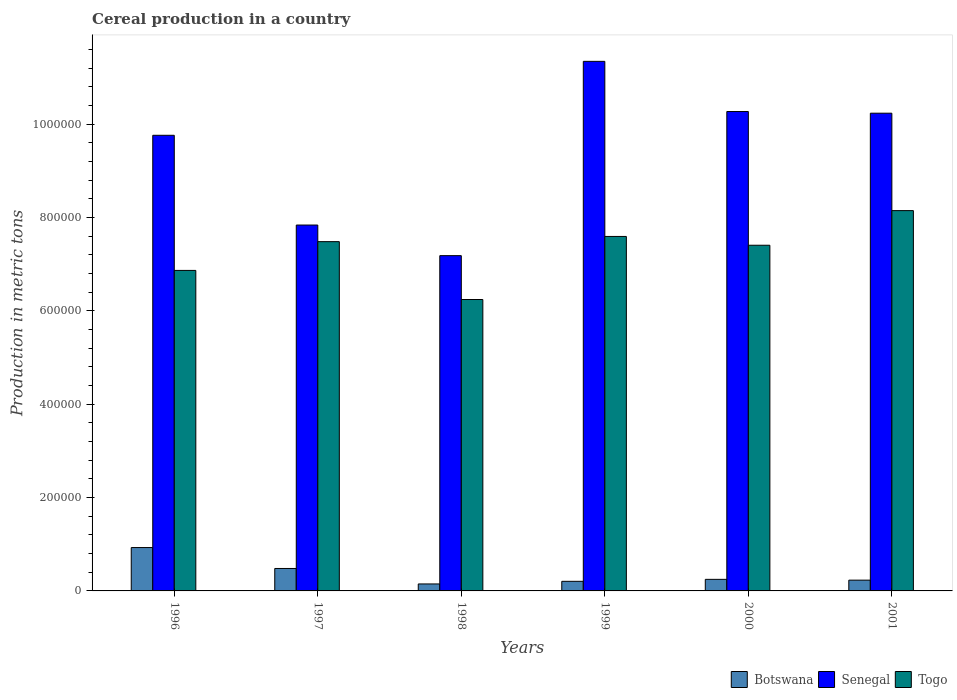Are the number of bars per tick equal to the number of legend labels?
Offer a very short reply. Yes. How many bars are there on the 4th tick from the left?
Your answer should be compact. 3. How many bars are there on the 2nd tick from the right?
Ensure brevity in your answer.  3. What is the label of the 5th group of bars from the left?
Ensure brevity in your answer.  2000. In how many cases, is the number of bars for a given year not equal to the number of legend labels?
Ensure brevity in your answer.  0. What is the total cereal production in Togo in 1996?
Your answer should be very brief. 6.87e+05. Across all years, what is the maximum total cereal production in Togo?
Give a very brief answer. 8.15e+05. Across all years, what is the minimum total cereal production in Botswana?
Your answer should be very brief. 1.49e+04. What is the total total cereal production in Botswana in the graph?
Provide a succinct answer. 2.24e+05. What is the difference between the total cereal production in Togo in 1996 and that in 1999?
Your answer should be very brief. -7.28e+04. What is the difference between the total cereal production in Senegal in 1997 and the total cereal production in Botswana in 1998?
Give a very brief answer. 7.69e+05. What is the average total cereal production in Senegal per year?
Provide a short and direct response. 9.44e+05. In the year 1998, what is the difference between the total cereal production in Togo and total cereal production in Senegal?
Your response must be concise. -9.40e+04. What is the ratio of the total cereal production in Botswana in 1997 to that in 2000?
Give a very brief answer. 1.94. What is the difference between the highest and the second highest total cereal production in Togo?
Give a very brief answer. 5.53e+04. What is the difference between the highest and the lowest total cereal production in Togo?
Your response must be concise. 1.90e+05. What does the 3rd bar from the left in 2001 represents?
Your answer should be very brief. Togo. What does the 3rd bar from the right in 2001 represents?
Keep it short and to the point. Botswana. Are all the bars in the graph horizontal?
Keep it short and to the point. No. How many years are there in the graph?
Provide a short and direct response. 6. What is the difference between two consecutive major ticks on the Y-axis?
Make the answer very short. 2.00e+05. Does the graph contain any zero values?
Offer a terse response. No. Where does the legend appear in the graph?
Offer a very short reply. Bottom right. How many legend labels are there?
Keep it short and to the point. 3. How are the legend labels stacked?
Provide a short and direct response. Horizontal. What is the title of the graph?
Your answer should be compact. Cereal production in a country. What is the label or title of the X-axis?
Offer a very short reply. Years. What is the label or title of the Y-axis?
Your response must be concise. Production in metric tons. What is the Production in metric tons in Botswana in 1996?
Offer a very short reply. 9.29e+04. What is the Production in metric tons of Senegal in 1996?
Offer a very short reply. 9.76e+05. What is the Production in metric tons in Togo in 1996?
Ensure brevity in your answer.  6.87e+05. What is the Production in metric tons of Botswana in 1997?
Keep it short and to the point. 4.81e+04. What is the Production in metric tons in Senegal in 1997?
Provide a short and direct response. 7.84e+05. What is the Production in metric tons in Togo in 1997?
Provide a succinct answer. 7.48e+05. What is the Production in metric tons of Botswana in 1998?
Your answer should be very brief. 1.49e+04. What is the Production in metric tons of Senegal in 1998?
Make the answer very short. 7.18e+05. What is the Production in metric tons of Togo in 1998?
Your answer should be very brief. 6.24e+05. What is the Production in metric tons of Botswana in 1999?
Offer a very short reply. 2.06e+04. What is the Production in metric tons of Senegal in 1999?
Your answer should be very brief. 1.13e+06. What is the Production in metric tons in Togo in 1999?
Offer a terse response. 7.59e+05. What is the Production in metric tons of Botswana in 2000?
Give a very brief answer. 2.48e+04. What is the Production in metric tons of Senegal in 2000?
Offer a terse response. 1.03e+06. What is the Production in metric tons in Togo in 2000?
Offer a terse response. 7.41e+05. What is the Production in metric tons in Botswana in 2001?
Offer a very short reply. 2.31e+04. What is the Production in metric tons of Senegal in 2001?
Keep it short and to the point. 1.02e+06. What is the Production in metric tons in Togo in 2001?
Provide a short and direct response. 8.15e+05. Across all years, what is the maximum Production in metric tons of Botswana?
Provide a short and direct response. 9.29e+04. Across all years, what is the maximum Production in metric tons in Senegal?
Ensure brevity in your answer.  1.13e+06. Across all years, what is the maximum Production in metric tons in Togo?
Make the answer very short. 8.15e+05. Across all years, what is the minimum Production in metric tons of Botswana?
Provide a succinct answer. 1.49e+04. Across all years, what is the minimum Production in metric tons in Senegal?
Provide a succinct answer. 7.18e+05. Across all years, what is the minimum Production in metric tons in Togo?
Give a very brief answer. 6.24e+05. What is the total Production in metric tons of Botswana in the graph?
Your response must be concise. 2.24e+05. What is the total Production in metric tons in Senegal in the graph?
Offer a terse response. 5.66e+06. What is the total Production in metric tons in Togo in the graph?
Provide a succinct answer. 4.37e+06. What is the difference between the Production in metric tons of Botswana in 1996 and that in 1997?
Your response must be concise. 4.48e+04. What is the difference between the Production in metric tons in Senegal in 1996 and that in 1997?
Your response must be concise. 1.92e+05. What is the difference between the Production in metric tons of Togo in 1996 and that in 1997?
Provide a short and direct response. -6.16e+04. What is the difference between the Production in metric tons in Botswana in 1996 and that in 1998?
Your response must be concise. 7.80e+04. What is the difference between the Production in metric tons of Senegal in 1996 and that in 1998?
Keep it short and to the point. 2.58e+05. What is the difference between the Production in metric tons of Togo in 1996 and that in 1998?
Your answer should be very brief. 6.23e+04. What is the difference between the Production in metric tons of Botswana in 1996 and that in 1999?
Provide a short and direct response. 7.23e+04. What is the difference between the Production in metric tons in Senegal in 1996 and that in 1999?
Your answer should be very brief. -1.58e+05. What is the difference between the Production in metric tons of Togo in 1996 and that in 1999?
Ensure brevity in your answer.  -7.28e+04. What is the difference between the Production in metric tons in Botswana in 1996 and that in 2000?
Offer a terse response. 6.81e+04. What is the difference between the Production in metric tons of Senegal in 1996 and that in 2000?
Offer a very short reply. -5.09e+04. What is the difference between the Production in metric tons of Togo in 1996 and that in 2000?
Your answer should be very brief. -5.39e+04. What is the difference between the Production in metric tons of Botswana in 1996 and that in 2001?
Offer a very short reply. 6.98e+04. What is the difference between the Production in metric tons of Senegal in 1996 and that in 2001?
Provide a short and direct response. -4.73e+04. What is the difference between the Production in metric tons in Togo in 1996 and that in 2001?
Your answer should be compact. -1.28e+05. What is the difference between the Production in metric tons of Botswana in 1997 and that in 1998?
Provide a succinct answer. 3.32e+04. What is the difference between the Production in metric tons in Senegal in 1997 and that in 1998?
Give a very brief answer. 6.56e+04. What is the difference between the Production in metric tons of Togo in 1997 and that in 1998?
Offer a very short reply. 1.24e+05. What is the difference between the Production in metric tons of Botswana in 1997 and that in 1999?
Your answer should be compact. 2.75e+04. What is the difference between the Production in metric tons in Senegal in 1997 and that in 1999?
Offer a very short reply. -3.51e+05. What is the difference between the Production in metric tons in Togo in 1997 and that in 1999?
Ensure brevity in your answer.  -1.12e+04. What is the difference between the Production in metric tons of Botswana in 1997 and that in 2000?
Provide a succinct answer. 2.33e+04. What is the difference between the Production in metric tons of Senegal in 1997 and that in 2000?
Make the answer very short. -2.43e+05. What is the difference between the Production in metric tons in Togo in 1997 and that in 2000?
Your response must be concise. 7701. What is the difference between the Production in metric tons in Botswana in 1997 and that in 2001?
Give a very brief answer. 2.50e+04. What is the difference between the Production in metric tons in Senegal in 1997 and that in 2001?
Provide a short and direct response. -2.40e+05. What is the difference between the Production in metric tons in Togo in 1997 and that in 2001?
Make the answer very short. -6.65e+04. What is the difference between the Production in metric tons of Botswana in 1998 and that in 1999?
Keep it short and to the point. -5644. What is the difference between the Production in metric tons of Senegal in 1998 and that in 1999?
Provide a succinct answer. -4.16e+05. What is the difference between the Production in metric tons in Togo in 1998 and that in 1999?
Your answer should be compact. -1.35e+05. What is the difference between the Production in metric tons of Botswana in 1998 and that in 2000?
Keep it short and to the point. -9842. What is the difference between the Production in metric tons of Senegal in 1998 and that in 2000?
Ensure brevity in your answer.  -3.09e+05. What is the difference between the Production in metric tons of Togo in 1998 and that in 2000?
Keep it short and to the point. -1.16e+05. What is the difference between the Production in metric tons in Botswana in 1998 and that in 2001?
Ensure brevity in your answer.  -8146. What is the difference between the Production in metric tons in Senegal in 1998 and that in 2001?
Offer a terse response. -3.05e+05. What is the difference between the Production in metric tons in Togo in 1998 and that in 2001?
Keep it short and to the point. -1.90e+05. What is the difference between the Production in metric tons in Botswana in 1999 and that in 2000?
Your response must be concise. -4198. What is the difference between the Production in metric tons in Senegal in 1999 and that in 2000?
Provide a succinct answer. 1.07e+05. What is the difference between the Production in metric tons in Togo in 1999 and that in 2000?
Provide a short and direct response. 1.89e+04. What is the difference between the Production in metric tons in Botswana in 1999 and that in 2001?
Your answer should be very brief. -2502. What is the difference between the Production in metric tons in Senegal in 1999 and that in 2001?
Offer a terse response. 1.11e+05. What is the difference between the Production in metric tons of Togo in 1999 and that in 2001?
Make the answer very short. -5.53e+04. What is the difference between the Production in metric tons of Botswana in 2000 and that in 2001?
Offer a terse response. 1696. What is the difference between the Production in metric tons in Senegal in 2000 and that in 2001?
Make the answer very short. 3565. What is the difference between the Production in metric tons in Togo in 2000 and that in 2001?
Your answer should be very brief. -7.42e+04. What is the difference between the Production in metric tons in Botswana in 1996 and the Production in metric tons in Senegal in 1997?
Give a very brief answer. -6.91e+05. What is the difference between the Production in metric tons in Botswana in 1996 and the Production in metric tons in Togo in 1997?
Ensure brevity in your answer.  -6.55e+05. What is the difference between the Production in metric tons of Senegal in 1996 and the Production in metric tons of Togo in 1997?
Provide a short and direct response. 2.28e+05. What is the difference between the Production in metric tons in Botswana in 1996 and the Production in metric tons in Senegal in 1998?
Keep it short and to the point. -6.25e+05. What is the difference between the Production in metric tons of Botswana in 1996 and the Production in metric tons of Togo in 1998?
Keep it short and to the point. -5.31e+05. What is the difference between the Production in metric tons in Senegal in 1996 and the Production in metric tons in Togo in 1998?
Provide a short and direct response. 3.52e+05. What is the difference between the Production in metric tons of Botswana in 1996 and the Production in metric tons of Senegal in 1999?
Provide a short and direct response. -1.04e+06. What is the difference between the Production in metric tons of Botswana in 1996 and the Production in metric tons of Togo in 1999?
Your response must be concise. -6.66e+05. What is the difference between the Production in metric tons in Senegal in 1996 and the Production in metric tons in Togo in 1999?
Offer a very short reply. 2.17e+05. What is the difference between the Production in metric tons in Botswana in 1996 and the Production in metric tons in Senegal in 2000?
Offer a very short reply. -9.34e+05. What is the difference between the Production in metric tons of Botswana in 1996 and the Production in metric tons of Togo in 2000?
Your answer should be compact. -6.48e+05. What is the difference between the Production in metric tons of Senegal in 1996 and the Production in metric tons of Togo in 2000?
Your answer should be very brief. 2.36e+05. What is the difference between the Production in metric tons in Botswana in 1996 and the Production in metric tons in Senegal in 2001?
Keep it short and to the point. -9.31e+05. What is the difference between the Production in metric tons of Botswana in 1996 and the Production in metric tons of Togo in 2001?
Offer a very short reply. -7.22e+05. What is the difference between the Production in metric tons in Senegal in 1996 and the Production in metric tons in Togo in 2001?
Give a very brief answer. 1.61e+05. What is the difference between the Production in metric tons of Botswana in 1997 and the Production in metric tons of Senegal in 1998?
Give a very brief answer. -6.70e+05. What is the difference between the Production in metric tons of Botswana in 1997 and the Production in metric tons of Togo in 1998?
Keep it short and to the point. -5.76e+05. What is the difference between the Production in metric tons of Senegal in 1997 and the Production in metric tons of Togo in 1998?
Offer a terse response. 1.60e+05. What is the difference between the Production in metric tons of Botswana in 1997 and the Production in metric tons of Senegal in 1999?
Offer a very short reply. -1.09e+06. What is the difference between the Production in metric tons in Botswana in 1997 and the Production in metric tons in Togo in 1999?
Your answer should be very brief. -7.11e+05. What is the difference between the Production in metric tons in Senegal in 1997 and the Production in metric tons in Togo in 1999?
Keep it short and to the point. 2.44e+04. What is the difference between the Production in metric tons in Botswana in 1997 and the Production in metric tons in Senegal in 2000?
Keep it short and to the point. -9.79e+05. What is the difference between the Production in metric tons of Botswana in 1997 and the Production in metric tons of Togo in 2000?
Your response must be concise. -6.92e+05. What is the difference between the Production in metric tons in Senegal in 1997 and the Production in metric tons in Togo in 2000?
Make the answer very short. 4.33e+04. What is the difference between the Production in metric tons of Botswana in 1997 and the Production in metric tons of Senegal in 2001?
Keep it short and to the point. -9.75e+05. What is the difference between the Production in metric tons of Botswana in 1997 and the Production in metric tons of Togo in 2001?
Provide a succinct answer. -7.67e+05. What is the difference between the Production in metric tons of Senegal in 1997 and the Production in metric tons of Togo in 2001?
Your response must be concise. -3.09e+04. What is the difference between the Production in metric tons in Botswana in 1998 and the Production in metric tons in Senegal in 1999?
Offer a very short reply. -1.12e+06. What is the difference between the Production in metric tons of Botswana in 1998 and the Production in metric tons of Togo in 1999?
Make the answer very short. -7.44e+05. What is the difference between the Production in metric tons of Senegal in 1998 and the Production in metric tons of Togo in 1999?
Provide a succinct answer. -4.11e+04. What is the difference between the Production in metric tons in Botswana in 1998 and the Production in metric tons in Senegal in 2000?
Provide a short and direct response. -1.01e+06. What is the difference between the Production in metric tons in Botswana in 1998 and the Production in metric tons in Togo in 2000?
Your answer should be compact. -7.26e+05. What is the difference between the Production in metric tons in Senegal in 1998 and the Production in metric tons in Togo in 2000?
Offer a terse response. -2.23e+04. What is the difference between the Production in metric tons of Botswana in 1998 and the Production in metric tons of Senegal in 2001?
Provide a succinct answer. -1.01e+06. What is the difference between the Production in metric tons in Botswana in 1998 and the Production in metric tons in Togo in 2001?
Your response must be concise. -8.00e+05. What is the difference between the Production in metric tons of Senegal in 1998 and the Production in metric tons of Togo in 2001?
Ensure brevity in your answer.  -9.65e+04. What is the difference between the Production in metric tons of Botswana in 1999 and the Production in metric tons of Senegal in 2000?
Offer a very short reply. -1.01e+06. What is the difference between the Production in metric tons in Botswana in 1999 and the Production in metric tons in Togo in 2000?
Provide a succinct answer. -7.20e+05. What is the difference between the Production in metric tons in Senegal in 1999 and the Production in metric tons in Togo in 2000?
Your answer should be very brief. 3.94e+05. What is the difference between the Production in metric tons of Botswana in 1999 and the Production in metric tons of Senegal in 2001?
Ensure brevity in your answer.  -1.00e+06. What is the difference between the Production in metric tons of Botswana in 1999 and the Production in metric tons of Togo in 2001?
Provide a short and direct response. -7.94e+05. What is the difference between the Production in metric tons in Senegal in 1999 and the Production in metric tons in Togo in 2001?
Give a very brief answer. 3.20e+05. What is the difference between the Production in metric tons of Botswana in 2000 and the Production in metric tons of Senegal in 2001?
Your response must be concise. -9.99e+05. What is the difference between the Production in metric tons in Botswana in 2000 and the Production in metric tons in Togo in 2001?
Your answer should be compact. -7.90e+05. What is the difference between the Production in metric tons of Senegal in 2000 and the Production in metric tons of Togo in 2001?
Give a very brief answer. 2.12e+05. What is the average Production in metric tons in Botswana per year?
Make the answer very short. 3.74e+04. What is the average Production in metric tons in Senegal per year?
Your answer should be compact. 9.44e+05. What is the average Production in metric tons in Togo per year?
Provide a short and direct response. 7.29e+05. In the year 1996, what is the difference between the Production in metric tons in Botswana and Production in metric tons in Senegal?
Ensure brevity in your answer.  -8.83e+05. In the year 1996, what is the difference between the Production in metric tons of Botswana and Production in metric tons of Togo?
Your response must be concise. -5.94e+05. In the year 1996, what is the difference between the Production in metric tons in Senegal and Production in metric tons in Togo?
Your response must be concise. 2.89e+05. In the year 1997, what is the difference between the Production in metric tons of Botswana and Production in metric tons of Senegal?
Offer a very short reply. -7.36e+05. In the year 1997, what is the difference between the Production in metric tons of Botswana and Production in metric tons of Togo?
Offer a very short reply. -7.00e+05. In the year 1997, what is the difference between the Production in metric tons of Senegal and Production in metric tons of Togo?
Make the answer very short. 3.56e+04. In the year 1998, what is the difference between the Production in metric tons in Botswana and Production in metric tons in Senegal?
Make the answer very short. -7.03e+05. In the year 1998, what is the difference between the Production in metric tons of Botswana and Production in metric tons of Togo?
Provide a succinct answer. -6.09e+05. In the year 1998, what is the difference between the Production in metric tons in Senegal and Production in metric tons in Togo?
Your response must be concise. 9.40e+04. In the year 1999, what is the difference between the Production in metric tons of Botswana and Production in metric tons of Senegal?
Give a very brief answer. -1.11e+06. In the year 1999, what is the difference between the Production in metric tons in Botswana and Production in metric tons in Togo?
Your answer should be very brief. -7.39e+05. In the year 1999, what is the difference between the Production in metric tons of Senegal and Production in metric tons of Togo?
Offer a very short reply. 3.75e+05. In the year 2000, what is the difference between the Production in metric tons in Botswana and Production in metric tons in Senegal?
Give a very brief answer. -1.00e+06. In the year 2000, what is the difference between the Production in metric tons in Botswana and Production in metric tons in Togo?
Your answer should be compact. -7.16e+05. In the year 2000, what is the difference between the Production in metric tons of Senegal and Production in metric tons of Togo?
Ensure brevity in your answer.  2.86e+05. In the year 2001, what is the difference between the Production in metric tons in Botswana and Production in metric tons in Senegal?
Make the answer very short. -1.00e+06. In the year 2001, what is the difference between the Production in metric tons in Botswana and Production in metric tons in Togo?
Your answer should be very brief. -7.92e+05. In the year 2001, what is the difference between the Production in metric tons of Senegal and Production in metric tons of Togo?
Provide a short and direct response. 2.09e+05. What is the ratio of the Production in metric tons in Botswana in 1996 to that in 1997?
Your response must be concise. 1.93. What is the ratio of the Production in metric tons in Senegal in 1996 to that in 1997?
Keep it short and to the point. 1.25. What is the ratio of the Production in metric tons of Togo in 1996 to that in 1997?
Your response must be concise. 0.92. What is the ratio of the Production in metric tons of Botswana in 1996 to that in 1998?
Make the answer very short. 6.22. What is the ratio of the Production in metric tons of Senegal in 1996 to that in 1998?
Your answer should be compact. 1.36. What is the ratio of the Production in metric tons in Togo in 1996 to that in 1998?
Your response must be concise. 1.1. What is the ratio of the Production in metric tons in Botswana in 1996 to that in 1999?
Your answer should be very brief. 4.51. What is the ratio of the Production in metric tons in Senegal in 1996 to that in 1999?
Your answer should be very brief. 0.86. What is the ratio of the Production in metric tons of Togo in 1996 to that in 1999?
Ensure brevity in your answer.  0.9. What is the ratio of the Production in metric tons in Botswana in 1996 to that in 2000?
Ensure brevity in your answer.  3.75. What is the ratio of the Production in metric tons of Senegal in 1996 to that in 2000?
Give a very brief answer. 0.95. What is the ratio of the Production in metric tons in Togo in 1996 to that in 2000?
Your answer should be very brief. 0.93. What is the ratio of the Production in metric tons in Botswana in 1996 to that in 2001?
Keep it short and to the point. 4.03. What is the ratio of the Production in metric tons of Senegal in 1996 to that in 2001?
Keep it short and to the point. 0.95. What is the ratio of the Production in metric tons in Togo in 1996 to that in 2001?
Offer a very short reply. 0.84. What is the ratio of the Production in metric tons of Botswana in 1997 to that in 1998?
Provide a succinct answer. 3.22. What is the ratio of the Production in metric tons in Senegal in 1997 to that in 1998?
Your answer should be compact. 1.09. What is the ratio of the Production in metric tons of Togo in 1997 to that in 1998?
Give a very brief answer. 1.2. What is the ratio of the Production in metric tons of Botswana in 1997 to that in 1999?
Your response must be concise. 2.34. What is the ratio of the Production in metric tons of Senegal in 1997 to that in 1999?
Give a very brief answer. 0.69. What is the ratio of the Production in metric tons in Botswana in 1997 to that in 2000?
Provide a short and direct response. 1.94. What is the ratio of the Production in metric tons of Senegal in 1997 to that in 2000?
Make the answer very short. 0.76. What is the ratio of the Production in metric tons of Togo in 1997 to that in 2000?
Your answer should be very brief. 1.01. What is the ratio of the Production in metric tons in Botswana in 1997 to that in 2001?
Your answer should be very brief. 2.08. What is the ratio of the Production in metric tons in Senegal in 1997 to that in 2001?
Your answer should be very brief. 0.77. What is the ratio of the Production in metric tons in Togo in 1997 to that in 2001?
Your answer should be compact. 0.92. What is the ratio of the Production in metric tons of Botswana in 1998 to that in 1999?
Provide a short and direct response. 0.73. What is the ratio of the Production in metric tons in Senegal in 1998 to that in 1999?
Your answer should be compact. 0.63. What is the ratio of the Production in metric tons of Togo in 1998 to that in 1999?
Your response must be concise. 0.82. What is the ratio of the Production in metric tons of Botswana in 1998 to that in 2000?
Provide a short and direct response. 0.6. What is the ratio of the Production in metric tons of Senegal in 1998 to that in 2000?
Ensure brevity in your answer.  0.7. What is the ratio of the Production in metric tons of Togo in 1998 to that in 2000?
Offer a terse response. 0.84. What is the ratio of the Production in metric tons in Botswana in 1998 to that in 2001?
Offer a terse response. 0.65. What is the ratio of the Production in metric tons in Senegal in 1998 to that in 2001?
Provide a succinct answer. 0.7. What is the ratio of the Production in metric tons of Togo in 1998 to that in 2001?
Ensure brevity in your answer.  0.77. What is the ratio of the Production in metric tons in Botswana in 1999 to that in 2000?
Provide a short and direct response. 0.83. What is the ratio of the Production in metric tons in Senegal in 1999 to that in 2000?
Provide a short and direct response. 1.1. What is the ratio of the Production in metric tons of Togo in 1999 to that in 2000?
Give a very brief answer. 1.03. What is the ratio of the Production in metric tons of Botswana in 1999 to that in 2001?
Make the answer very short. 0.89. What is the ratio of the Production in metric tons in Senegal in 1999 to that in 2001?
Provide a succinct answer. 1.11. What is the ratio of the Production in metric tons in Togo in 1999 to that in 2001?
Keep it short and to the point. 0.93. What is the ratio of the Production in metric tons in Botswana in 2000 to that in 2001?
Provide a succinct answer. 1.07. What is the ratio of the Production in metric tons of Togo in 2000 to that in 2001?
Provide a short and direct response. 0.91. What is the difference between the highest and the second highest Production in metric tons in Botswana?
Keep it short and to the point. 4.48e+04. What is the difference between the highest and the second highest Production in metric tons of Senegal?
Keep it short and to the point. 1.07e+05. What is the difference between the highest and the second highest Production in metric tons in Togo?
Provide a succinct answer. 5.53e+04. What is the difference between the highest and the lowest Production in metric tons of Botswana?
Offer a terse response. 7.80e+04. What is the difference between the highest and the lowest Production in metric tons in Senegal?
Your answer should be very brief. 4.16e+05. What is the difference between the highest and the lowest Production in metric tons of Togo?
Offer a terse response. 1.90e+05. 